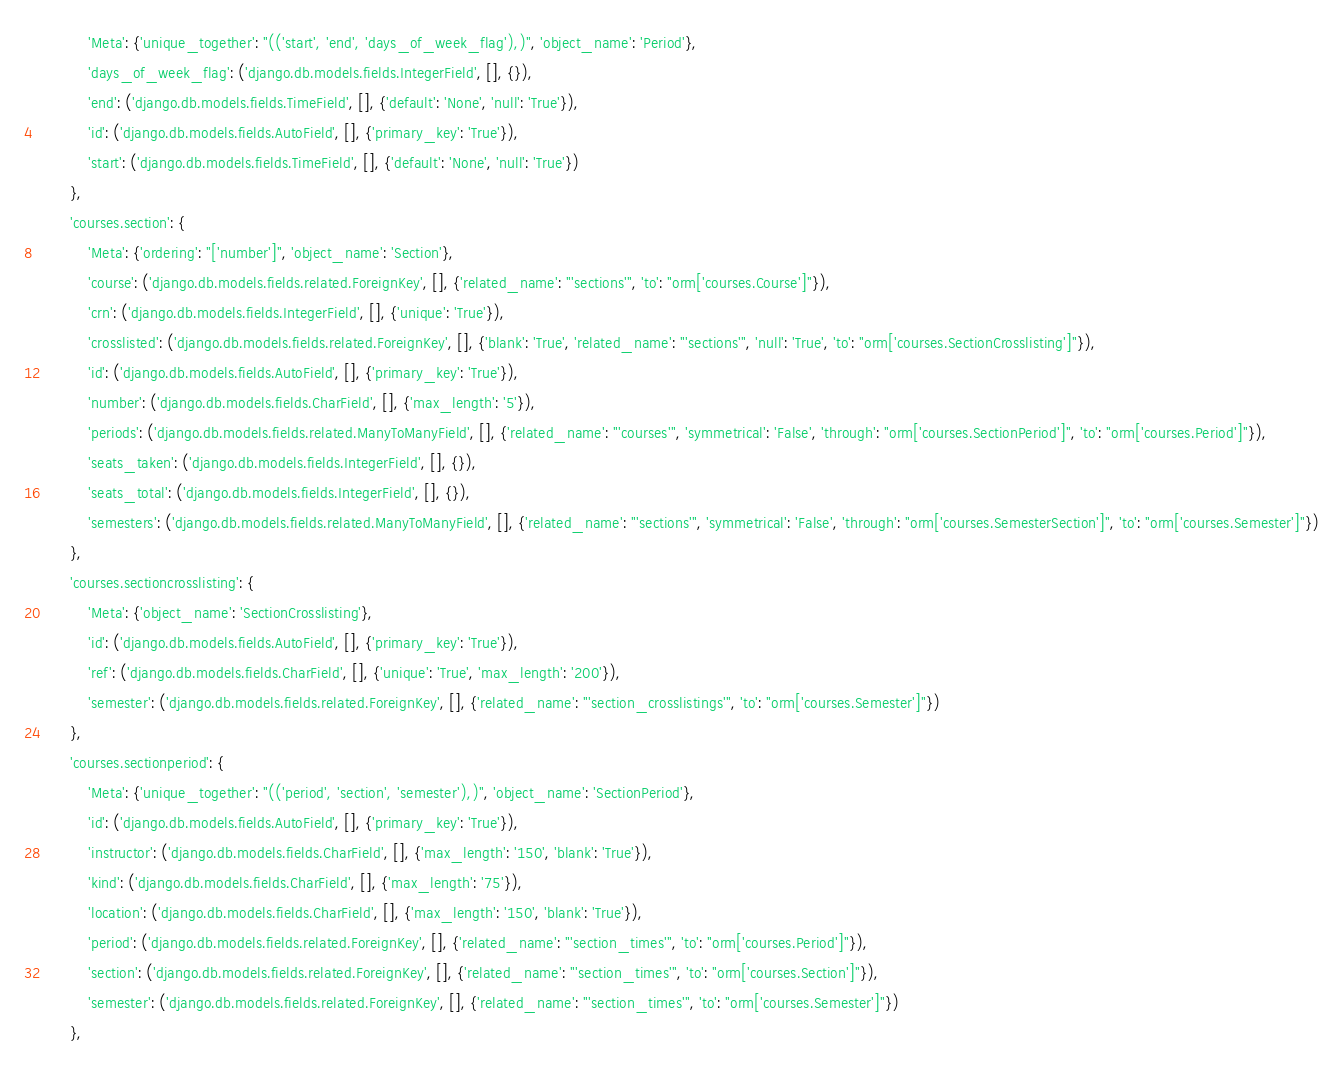<code> <loc_0><loc_0><loc_500><loc_500><_Python_>            'Meta': {'unique_together': "(('start', 'end', 'days_of_week_flag'),)", 'object_name': 'Period'},
            'days_of_week_flag': ('django.db.models.fields.IntegerField', [], {}),
            'end': ('django.db.models.fields.TimeField', [], {'default': 'None', 'null': 'True'}),
            'id': ('django.db.models.fields.AutoField', [], {'primary_key': 'True'}),
            'start': ('django.db.models.fields.TimeField', [], {'default': 'None', 'null': 'True'})
        },
        'courses.section': {
            'Meta': {'ordering': "['number']", 'object_name': 'Section'},
            'course': ('django.db.models.fields.related.ForeignKey', [], {'related_name': "'sections'", 'to': "orm['courses.Course']"}),
            'crn': ('django.db.models.fields.IntegerField', [], {'unique': 'True'}),
            'crosslisted': ('django.db.models.fields.related.ForeignKey', [], {'blank': 'True', 'related_name': "'sections'", 'null': 'True', 'to': "orm['courses.SectionCrosslisting']"}),
            'id': ('django.db.models.fields.AutoField', [], {'primary_key': 'True'}),
            'number': ('django.db.models.fields.CharField', [], {'max_length': '5'}),
            'periods': ('django.db.models.fields.related.ManyToManyField', [], {'related_name': "'courses'", 'symmetrical': 'False', 'through': "orm['courses.SectionPeriod']", 'to': "orm['courses.Period']"}),
            'seats_taken': ('django.db.models.fields.IntegerField', [], {}),
            'seats_total': ('django.db.models.fields.IntegerField', [], {}),
            'semesters': ('django.db.models.fields.related.ManyToManyField', [], {'related_name': "'sections'", 'symmetrical': 'False', 'through': "orm['courses.SemesterSection']", 'to': "orm['courses.Semester']"})
        },
        'courses.sectioncrosslisting': {
            'Meta': {'object_name': 'SectionCrosslisting'},
            'id': ('django.db.models.fields.AutoField', [], {'primary_key': 'True'}),
            'ref': ('django.db.models.fields.CharField', [], {'unique': 'True', 'max_length': '200'}),
            'semester': ('django.db.models.fields.related.ForeignKey', [], {'related_name': "'section_crosslistings'", 'to': "orm['courses.Semester']"})
        },
        'courses.sectionperiod': {
            'Meta': {'unique_together': "(('period', 'section', 'semester'),)", 'object_name': 'SectionPeriod'},
            'id': ('django.db.models.fields.AutoField', [], {'primary_key': 'True'}),
            'instructor': ('django.db.models.fields.CharField', [], {'max_length': '150', 'blank': 'True'}),
            'kind': ('django.db.models.fields.CharField', [], {'max_length': '75'}),
            'location': ('django.db.models.fields.CharField', [], {'max_length': '150', 'blank': 'True'}),
            'period': ('django.db.models.fields.related.ForeignKey', [], {'related_name': "'section_times'", 'to': "orm['courses.Period']"}),
            'section': ('django.db.models.fields.related.ForeignKey', [], {'related_name': "'section_times'", 'to': "orm['courses.Section']"}),
            'semester': ('django.db.models.fields.related.ForeignKey', [], {'related_name': "'section_times'", 'to': "orm['courses.Semester']"})
        },</code> 